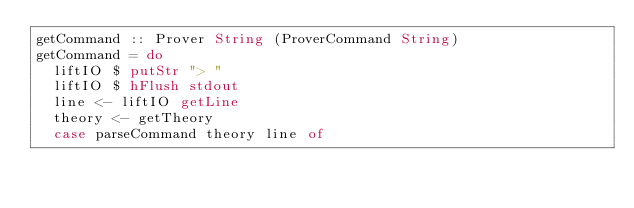<code> <loc_0><loc_0><loc_500><loc_500><_Haskell_>getCommand :: Prover String (ProverCommand String)
getCommand = do
  liftIO $ putStr "> "
  liftIO $ hFlush stdout
  line <- liftIO getLine
  theory <- getTheory
  case parseCommand theory line of</code> 